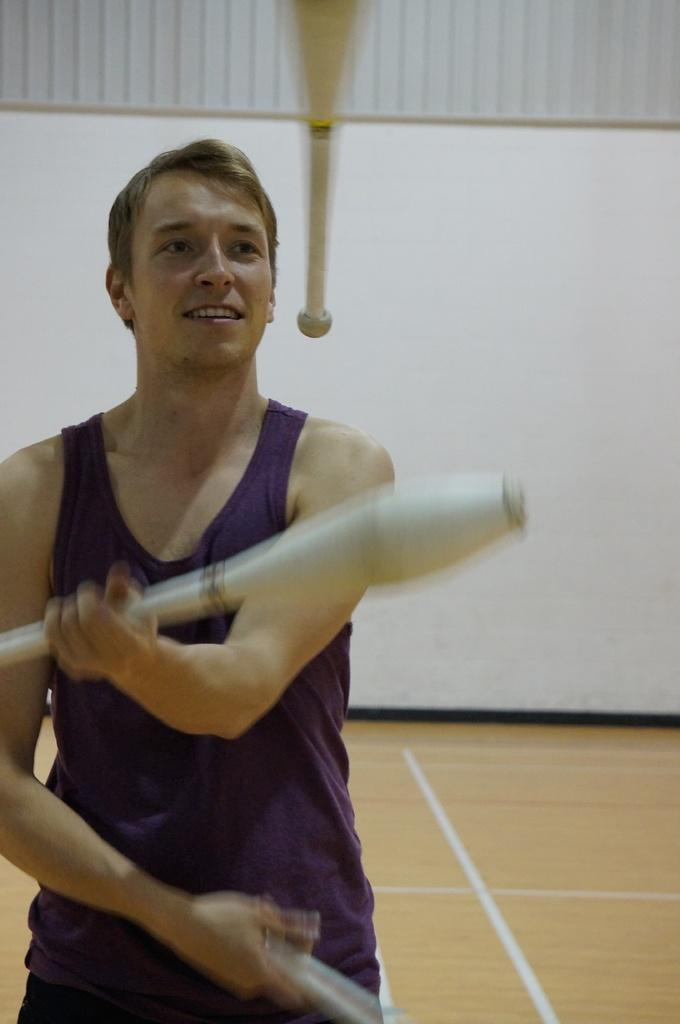What is happening in the image? There is a person in the image, and they are juggling. What can be said about the objects being juggled? The objects being juggled are white in color. What type of pancake is being juggled in the image? There is no pancake present in the image; the person is juggling white objects. 